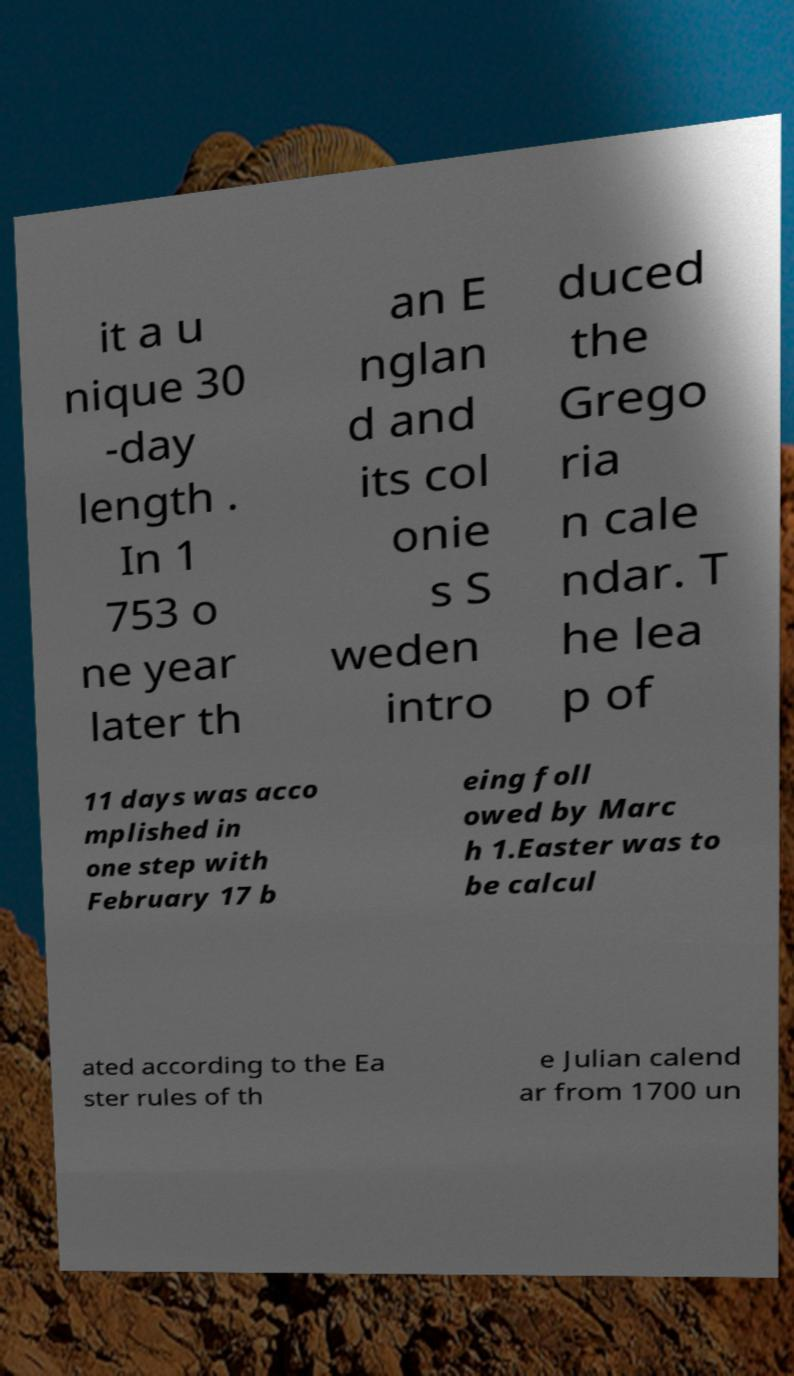Could you assist in decoding the text presented in this image and type it out clearly? it a u nique 30 -day length . In 1 753 o ne year later th an E nglan d and its col onie s S weden intro duced the Grego ria n cale ndar. T he lea p of 11 days was acco mplished in one step with February 17 b eing foll owed by Marc h 1.Easter was to be calcul ated according to the Ea ster rules of th e Julian calend ar from 1700 un 